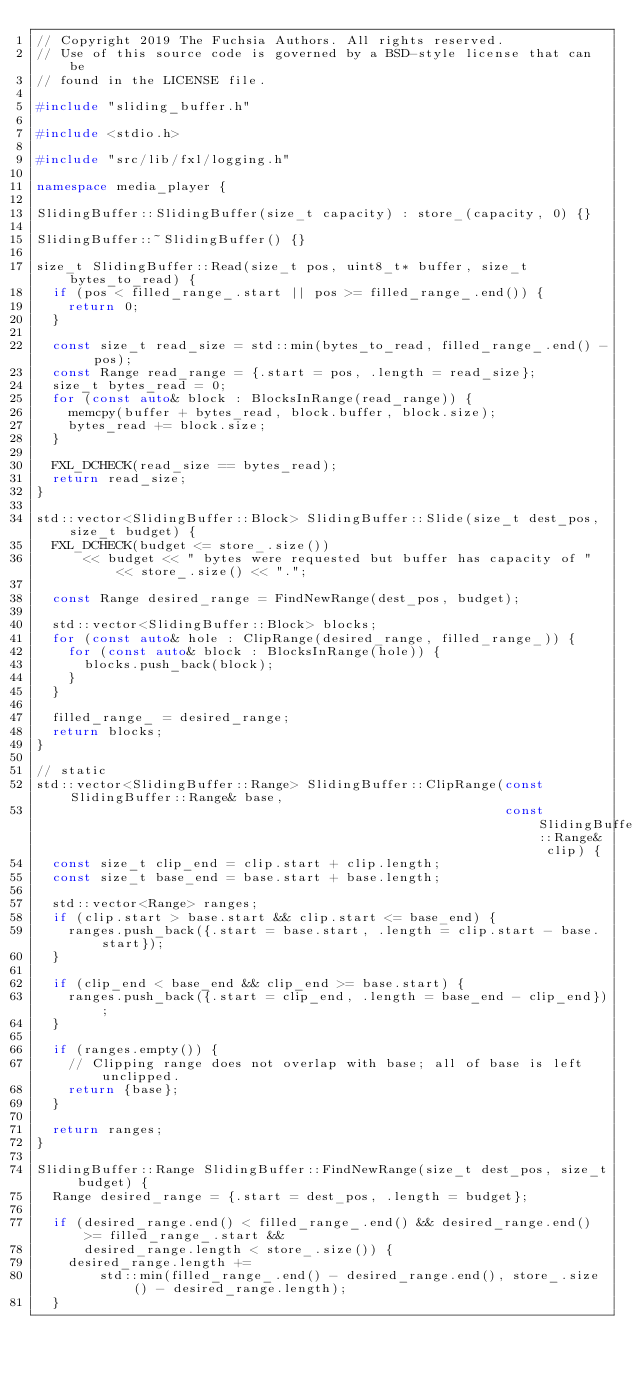<code> <loc_0><loc_0><loc_500><loc_500><_C++_>// Copyright 2019 The Fuchsia Authors. All rights reserved.
// Use of this source code is governed by a BSD-style license that can be
// found in the LICENSE file.

#include "sliding_buffer.h"

#include <stdio.h>

#include "src/lib/fxl/logging.h"

namespace media_player {

SlidingBuffer::SlidingBuffer(size_t capacity) : store_(capacity, 0) {}

SlidingBuffer::~SlidingBuffer() {}

size_t SlidingBuffer::Read(size_t pos, uint8_t* buffer, size_t bytes_to_read) {
  if (pos < filled_range_.start || pos >= filled_range_.end()) {
    return 0;
  }

  const size_t read_size = std::min(bytes_to_read, filled_range_.end() - pos);
  const Range read_range = {.start = pos, .length = read_size};
  size_t bytes_read = 0;
  for (const auto& block : BlocksInRange(read_range)) {
    memcpy(buffer + bytes_read, block.buffer, block.size);
    bytes_read += block.size;
  }

  FXL_DCHECK(read_size == bytes_read);
  return read_size;
}

std::vector<SlidingBuffer::Block> SlidingBuffer::Slide(size_t dest_pos, size_t budget) {
  FXL_DCHECK(budget <= store_.size())
      << budget << " bytes were requested but buffer has capacity of " << store_.size() << ".";

  const Range desired_range = FindNewRange(dest_pos, budget);

  std::vector<SlidingBuffer::Block> blocks;
  for (const auto& hole : ClipRange(desired_range, filled_range_)) {
    for (const auto& block : BlocksInRange(hole)) {
      blocks.push_back(block);
    }
  }

  filled_range_ = desired_range;
  return blocks;
}

// static
std::vector<SlidingBuffer::Range> SlidingBuffer::ClipRange(const SlidingBuffer::Range& base,
                                                           const SlidingBuffer::Range& clip) {
  const size_t clip_end = clip.start + clip.length;
  const size_t base_end = base.start + base.length;

  std::vector<Range> ranges;
  if (clip.start > base.start && clip.start <= base_end) {
    ranges.push_back({.start = base.start, .length = clip.start - base.start});
  }

  if (clip_end < base_end && clip_end >= base.start) {
    ranges.push_back({.start = clip_end, .length = base_end - clip_end});
  }

  if (ranges.empty()) {
    // Clipping range does not overlap with base; all of base is left unclipped.
    return {base};
  }

  return ranges;
}

SlidingBuffer::Range SlidingBuffer::FindNewRange(size_t dest_pos, size_t budget) {
  Range desired_range = {.start = dest_pos, .length = budget};

  if (desired_range.end() < filled_range_.end() && desired_range.end() >= filled_range_.start &&
      desired_range.length < store_.size()) {
    desired_range.length +=
        std::min(filled_range_.end() - desired_range.end(), store_.size() - desired_range.length);
  }
</code> 